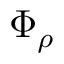<formula> <loc_0><loc_0><loc_500><loc_500>\Phi _ { \rho }</formula> 